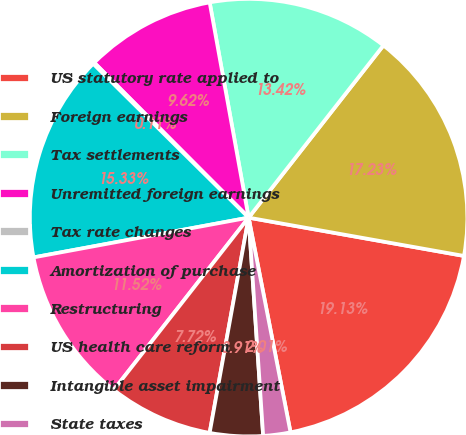Convert chart to OTSL. <chart><loc_0><loc_0><loc_500><loc_500><pie_chart><fcel>US statutory rate applied to<fcel>Foreign earnings<fcel>Tax settlements<fcel>Unremitted foreign earnings<fcel>Tax rate changes<fcel>Amortization of purchase<fcel>Restructuring<fcel>US health care reform<fcel>Intangible asset impairment<fcel>State taxes<nl><fcel>19.13%<fcel>17.23%<fcel>13.42%<fcel>9.62%<fcel>0.11%<fcel>15.33%<fcel>11.52%<fcel>7.72%<fcel>3.91%<fcel>2.01%<nl></chart> 